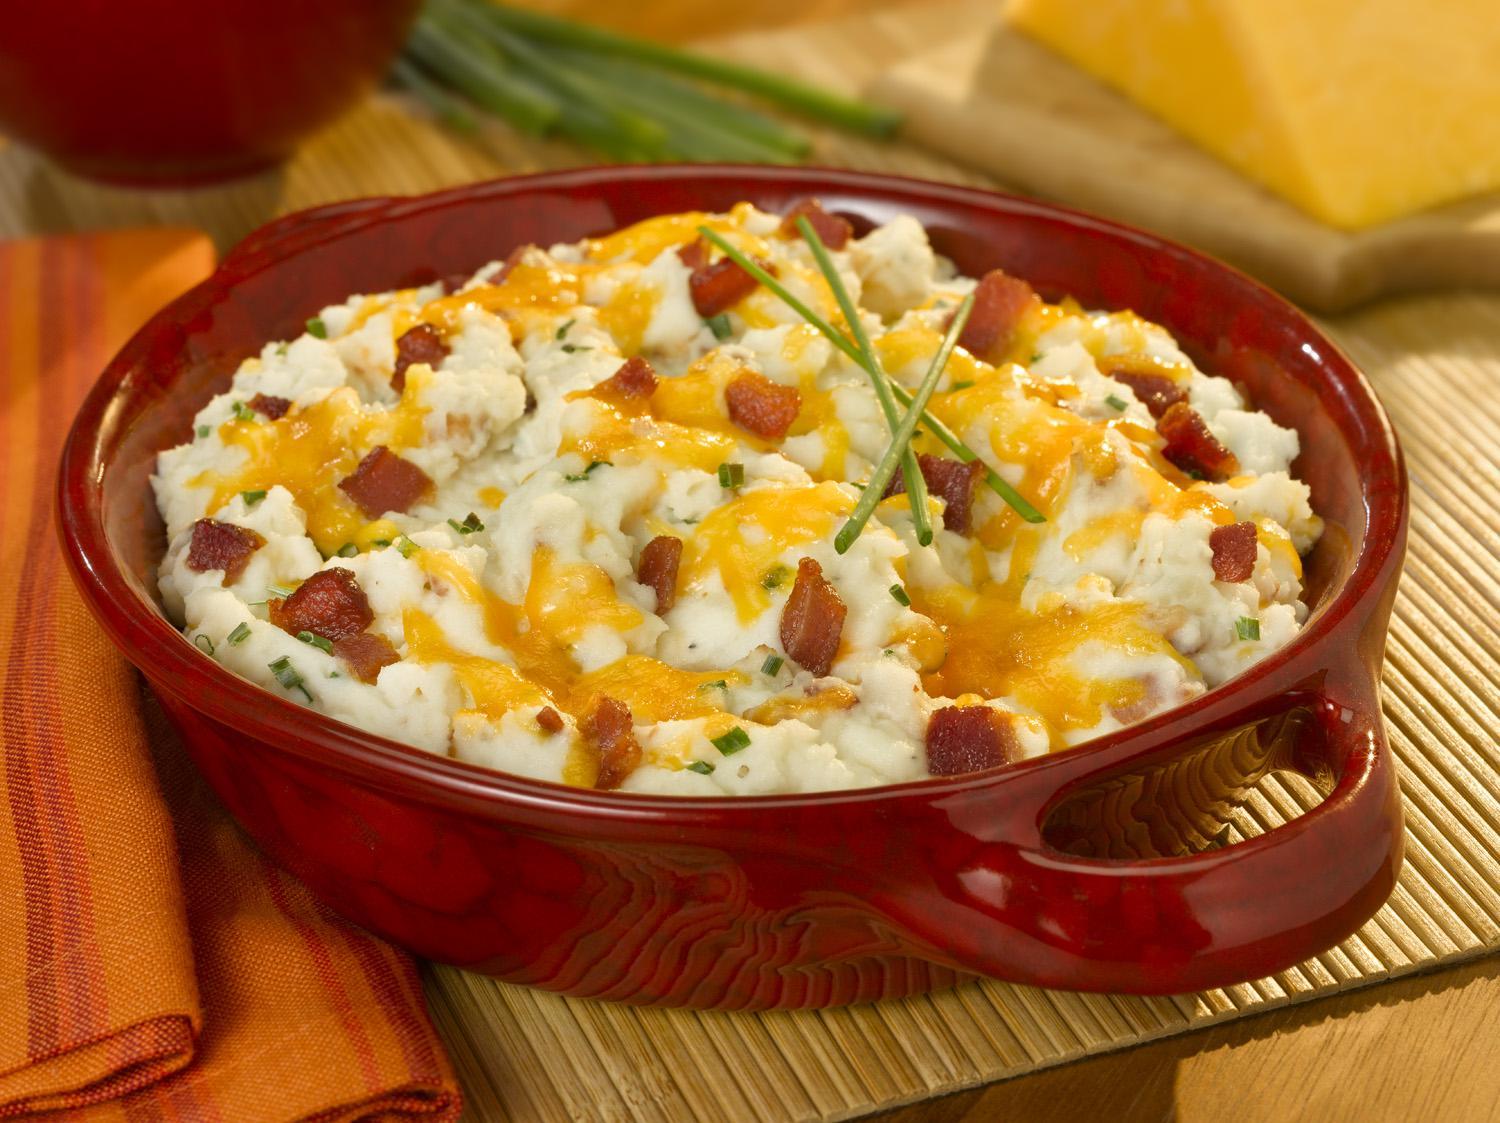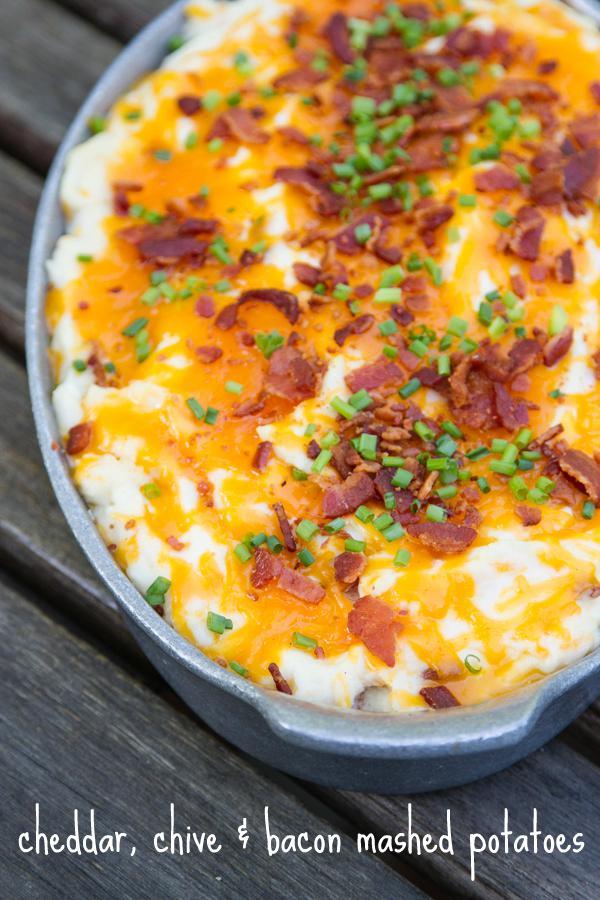The first image is the image on the left, the second image is the image on the right. Considering the images on both sides, is "At least one of the dishes has visible handles" valid? Answer yes or no. Yes. 